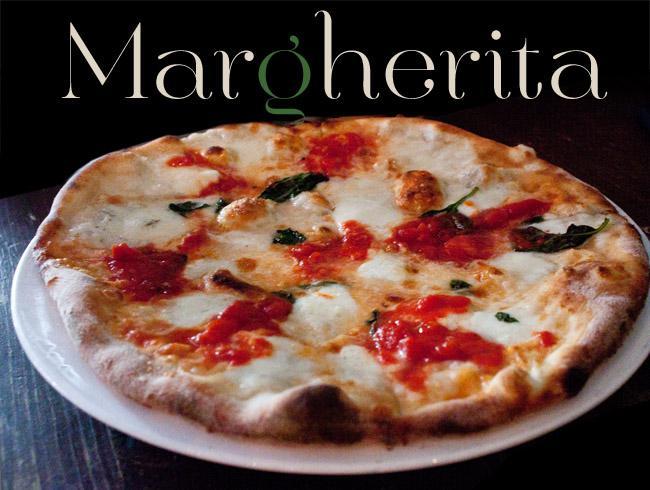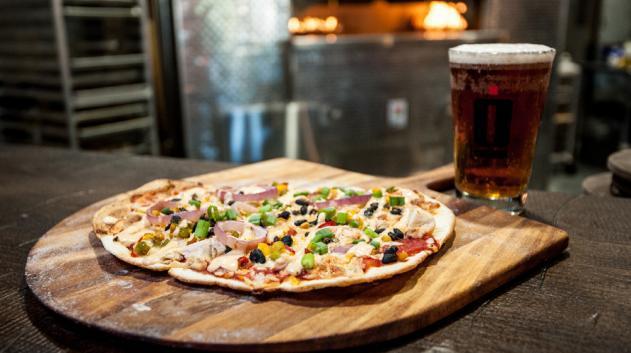The first image is the image on the left, the second image is the image on the right. Evaluate the accuracy of this statement regarding the images: "In the image on the right, there is at least one full mug of beer sitting on the table to the right of the pizza.". Is it true? Answer yes or no. Yes. The first image is the image on the left, the second image is the image on the right. Examine the images to the left and right. Is the description "The right image includes a filled glass of amber beer with foam on top, behind a round pizza with a thin crust." accurate? Answer yes or no. Yes. 